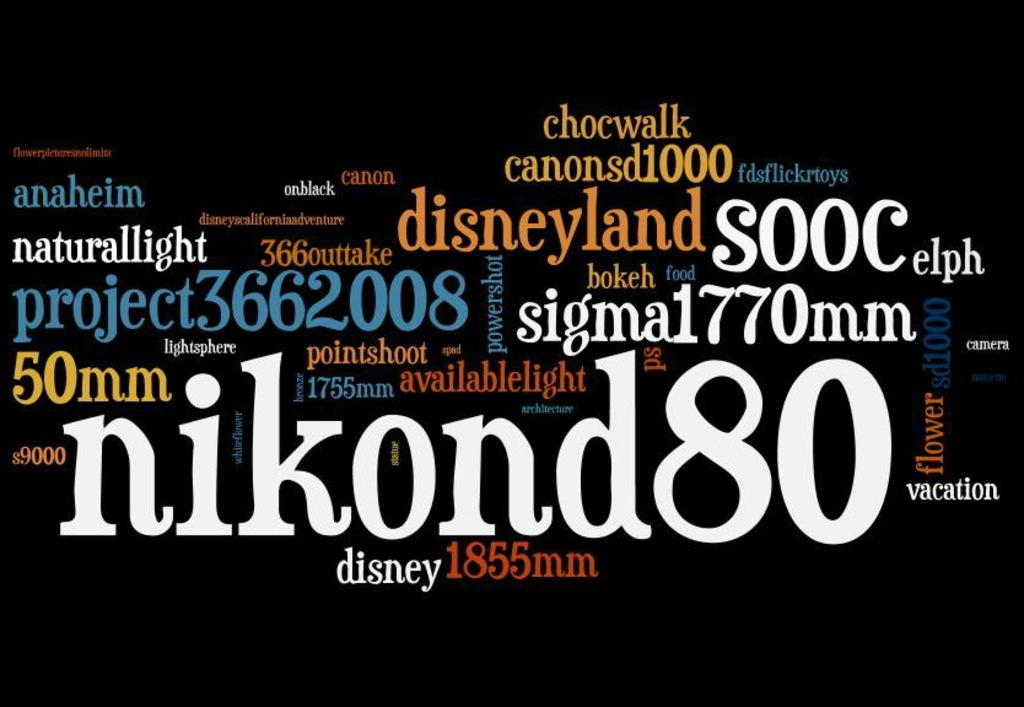<image>
Summarize the visual content of the image. A bunch of words arranged in a pattern in different colors with nikond being most prominent. 